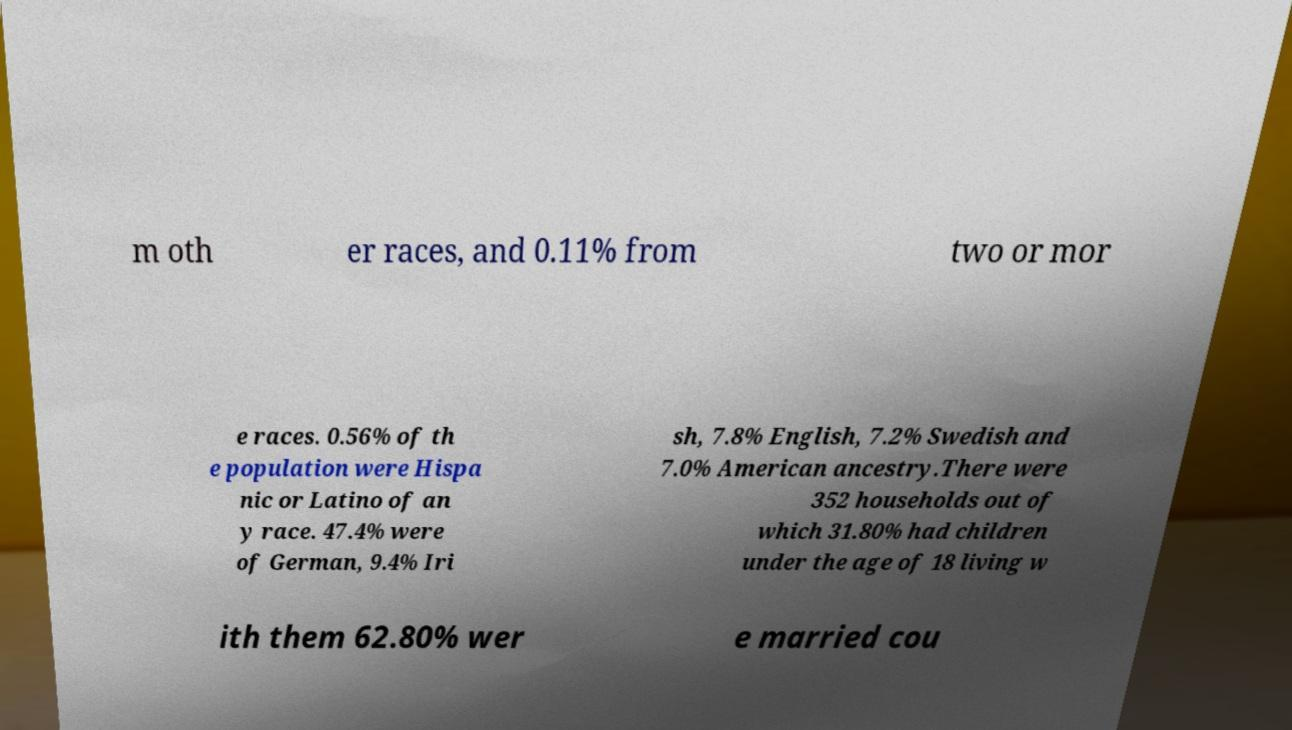Please read and relay the text visible in this image. What does it say? m oth er races, and 0.11% from two or mor e races. 0.56% of th e population were Hispa nic or Latino of an y race. 47.4% were of German, 9.4% Iri sh, 7.8% English, 7.2% Swedish and 7.0% American ancestry.There were 352 households out of which 31.80% had children under the age of 18 living w ith them 62.80% wer e married cou 